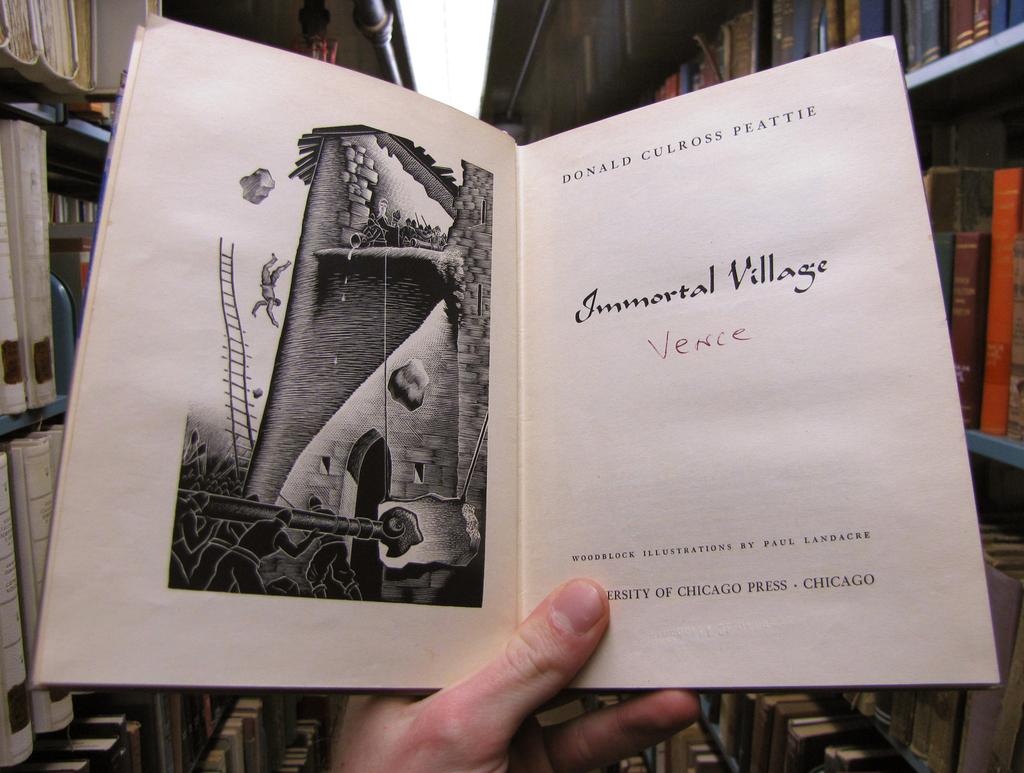Who is the author of the work?
Give a very brief answer. Donald culross peattie. 